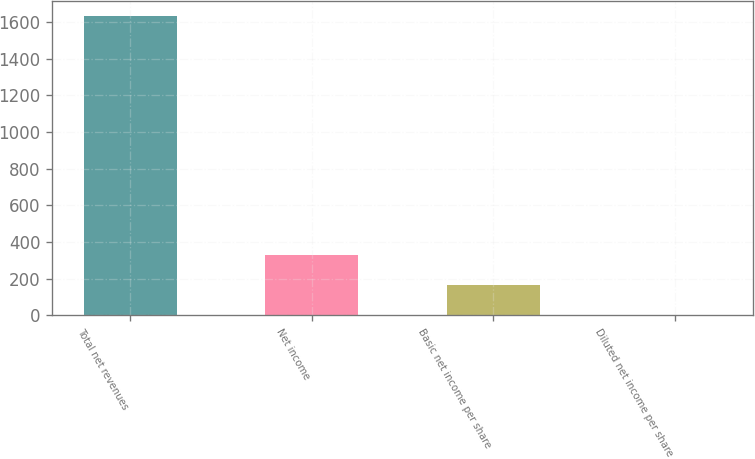<chart> <loc_0><loc_0><loc_500><loc_500><bar_chart><fcel>Total net revenues<fcel>Net income<fcel>Basic net income per share<fcel>Diluted net income per share<nl><fcel>1632.2<fcel>329.4<fcel>164.42<fcel>1.33<nl></chart> 